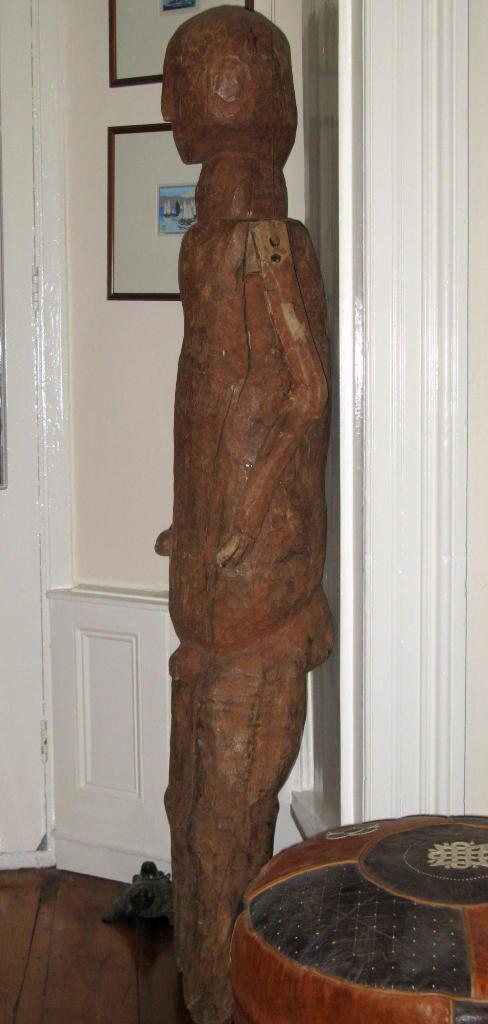What is the main subject in the center of the image? There is a sculpture in the center of the image. What can be seen in the background of the image? There are frames in the background of the image. How many bees are buzzing around the sculpture in the image? There are no bees present in the image; it only features a sculpture and frames in the background. 